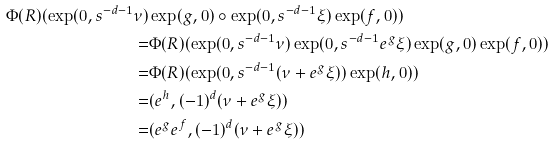<formula> <loc_0><loc_0><loc_500><loc_500>\Phi ( R ) ( \exp ( 0 , s ^ { - d - 1 } \nu ) & \exp ( g , 0 ) \circ \exp ( 0 , s ^ { - d - 1 } \xi ) \exp ( f , 0 ) ) \\ = & \Phi ( R ) ( \exp ( 0 , s ^ { - d - 1 } \nu ) \exp ( 0 , s ^ { - d - 1 } e ^ { g } \xi ) \exp ( g , 0 ) \exp ( f , 0 ) ) \\ = & \Phi ( R ) ( \exp ( 0 , s ^ { - d - 1 } ( \nu + e ^ { g } \xi ) ) \exp ( h , 0 ) ) \\ = & ( e ^ { h } , ( - 1 ) ^ { d } ( \nu + e ^ { g } \xi ) ) \\ = & ( e ^ { g } e ^ { f } , ( - 1 ) ^ { d } ( \nu + e ^ { g } \xi ) )</formula> 